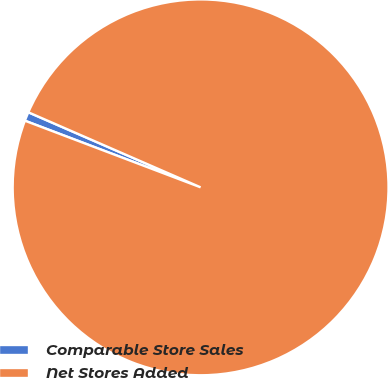<chart> <loc_0><loc_0><loc_500><loc_500><pie_chart><fcel>Comparable Store Sales<fcel>Net Stores Added<nl><fcel>0.77%<fcel>99.23%<nl></chart> 